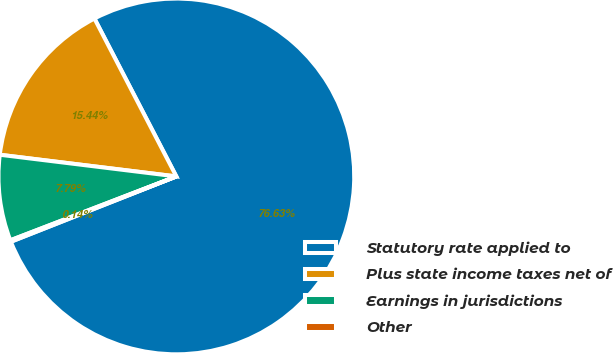<chart> <loc_0><loc_0><loc_500><loc_500><pie_chart><fcel>Statutory rate applied to<fcel>Plus state income taxes net of<fcel>Earnings in jurisdictions<fcel>Other<nl><fcel>76.64%<fcel>15.44%<fcel>7.79%<fcel>0.14%<nl></chart> 